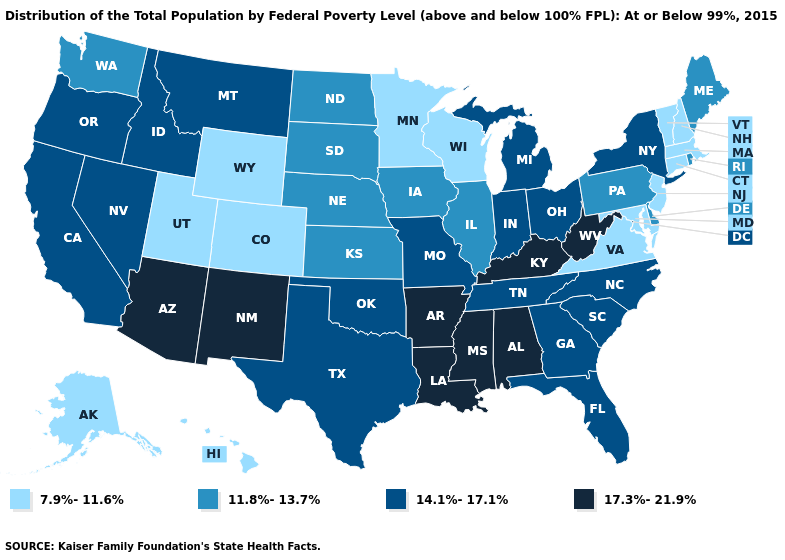Among the states that border New Hampshire , does Vermont have the highest value?
Short answer required. No. Does Rhode Island have the lowest value in the Northeast?
Concise answer only. No. What is the value of Wyoming?
Quick response, please. 7.9%-11.6%. How many symbols are there in the legend?
Answer briefly. 4. What is the lowest value in states that border New Mexico?
Keep it brief. 7.9%-11.6%. Does the first symbol in the legend represent the smallest category?
Write a very short answer. Yes. What is the value of Idaho?
Write a very short answer. 14.1%-17.1%. What is the value of Nebraska?
Short answer required. 11.8%-13.7%. Is the legend a continuous bar?
Answer briefly. No. Name the states that have a value in the range 7.9%-11.6%?
Answer briefly. Alaska, Colorado, Connecticut, Hawaii, Maryland, Massachusetts, Minnesota, New Hampshire, New Jersey, Utah, Vermont, Virginia, Wisconsin, Wyoming. What is the lowest value in states that border Massachusetts?
Concise answer only. 7.9%-11.6%. Name the states that have a value in the range 14.1%-17.1%?
Write a very short answer. California, Florida, Georgia, Idaho, Indiana, Michigan, Missouri, Montana, Nevada, New York, North Carolina, Ohio, Oklahoma, Oregon, South Carolina, Tennessee, Texas. Name the states that have a value in the range 17.3%-21.9%?
Give a very brief answer. Alabama, Arizona, Arkansas, Kentucky, Louisiana, Mississippi, New Mexico, West Virginia. Among the states that border Ohio , which have the lowest value?
Concise answer only. Pennsylvania. Name the states that have a value in the range 11.8%-13.7%?
Short answer required. Delaware, Illinois, Iowa, Kansas, Maine, Nebraska, North Dakota, Pennsylvania, Rhode Island, South Dakota, Washington. 